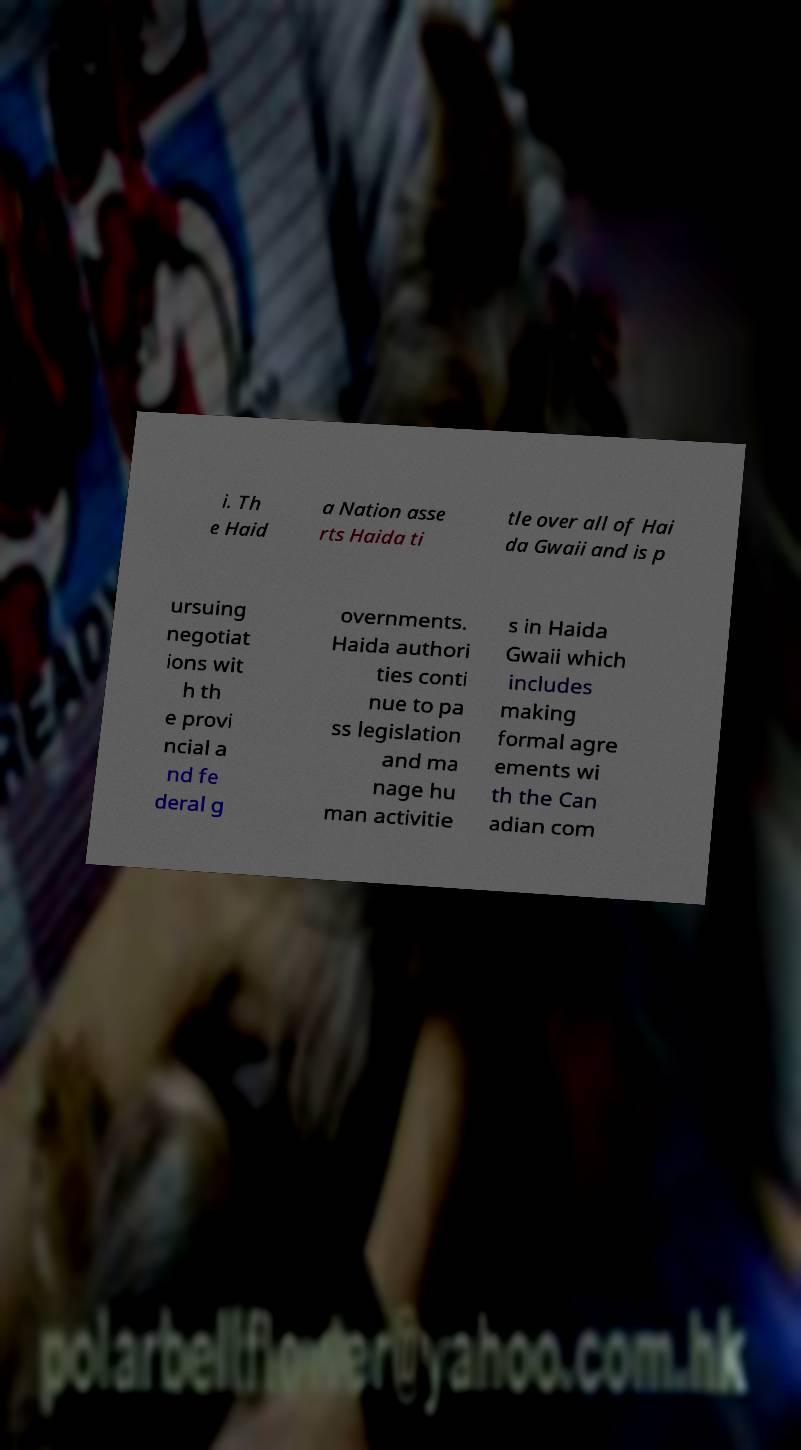For documentation purposes, I need the text within this image transcribed. Could you provide that? i. Th e Haid a Nation asse rts Haida ti tle over all of Hai da Gwaii and is p ursuing negotiat ions wit h th e provi ncial a nd fe deral g overnments. Haida authori ties conti nue to pa ss legislation and ma nage hu man activitie s in Haida Gwaii which includes making formal agre ements wi th the Can adian com 